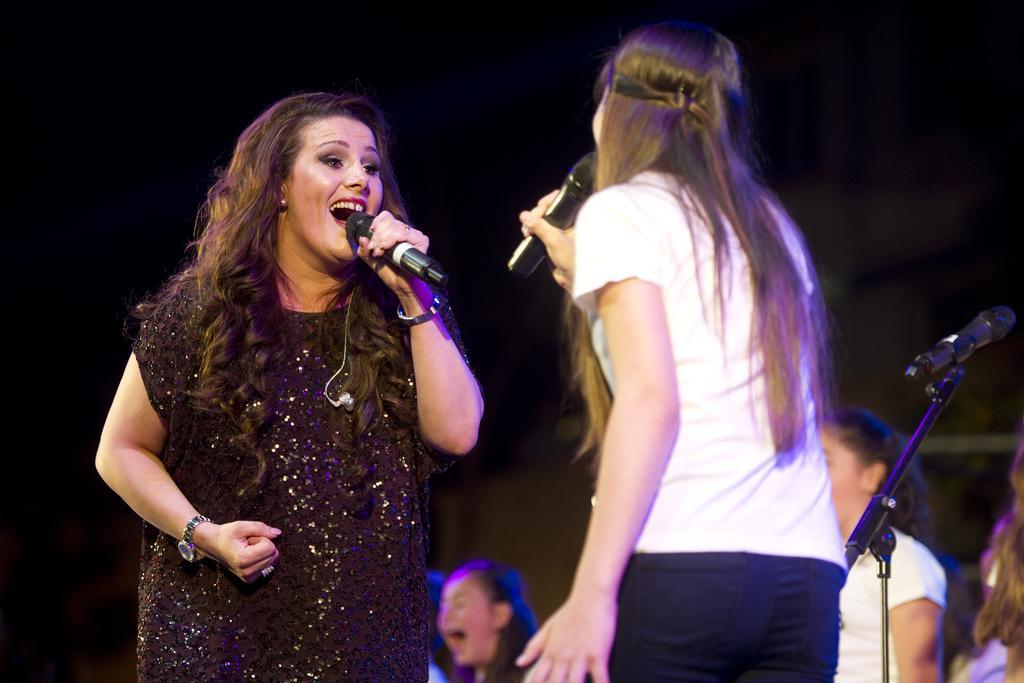How would you summarize this image in a sentence or two? This picture shows two women singing with the help of a microphone. 